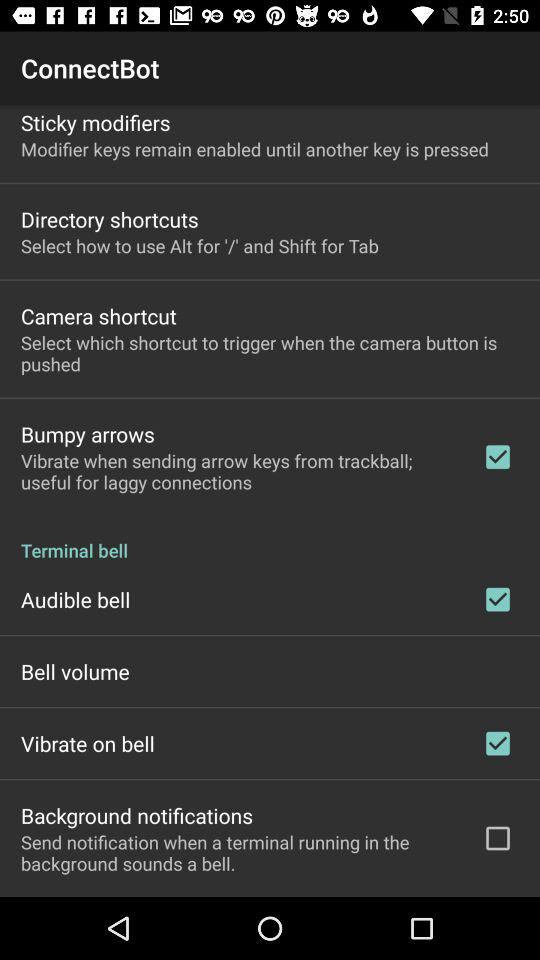What is the status of "Audible bell"? The status is "on". 